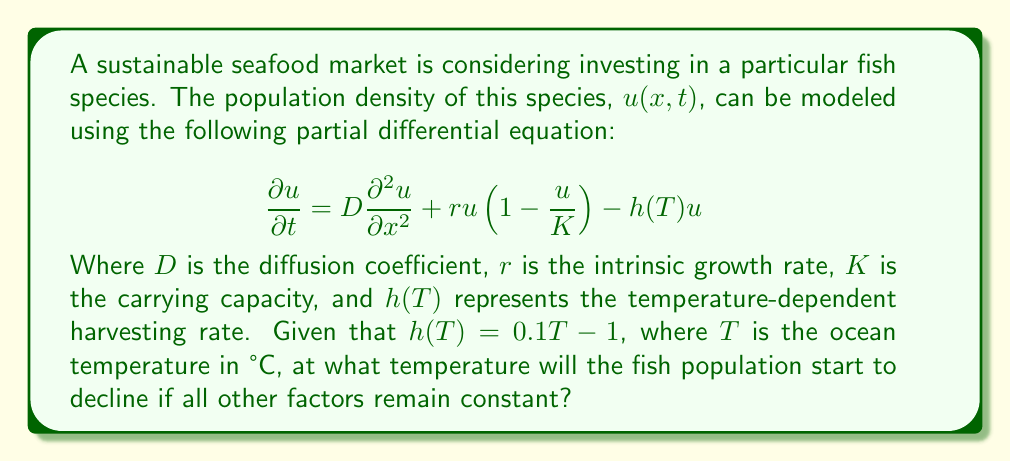Can you solve this math problem? To determine the temperature at which the fish population starts to decline, we need to analyze the equation and find the point where the rate of change of the population becomes negative. Let's approach this step-by-step:

1) The population will start to decline when $\frac{\partial u}{\partial t} < 0$. 

2) For simplicity, let's consider a homogeneous distribution where $\frac{\partial^2 u}{\partial x^2} = 0$. This allows us to focus on the temporal dynamics.

3) Our equation now becomes:

   $$\frac{\partial u}{\partial t} = ru(1-\frac{u}{K}) - h(T)u$$

4) For the population to start declining, we need:

   $$ru(1-\frac{u}{K}) - h(T)u < 0$$

5) Dividing both sides by $u$ (assuming $u \neq 0$):

   $$r(1-\frac{u}{K}) - h(T) < 0$$

6) The left side of this inequality will be at its maximum when $u$ is very small compared to $K$. In this case, we can approximate:

   $$r - h(T) < 0$$

7) Substituting the given function for $h(T)$:

   $$r - (0.1T - 1) < 0$$

8) Solving this inequality:

   $$r + 1 < 0.1T$$
   $$T > \frac{r + 1}{0.1} = 10(r + 1)$$

Therefore, the fish population will start to decline when the ocean temperature exceeds $10(r + 1)$ °C, assuming all other factors remain constant.
Answer: $T > 10(r + 1)$ °C 